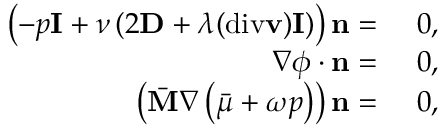Convert formula to latex. <formula><loc_0><loc_0><loc_500><loc_500>\begin{array} { r l } { \left ( - p I + \nu \left ( 2 D + \lambda ( d i v v ) I \right ) \right ) n = } & { 0 , } \\ { \nabla \phi \cdot n = } & { 0 , } \\ { \left ( \bar { M } \nabla \left ( \bar { \mu } + \omega p \right ) \right ) n = } & { 0 , } \end{array}</formula> 